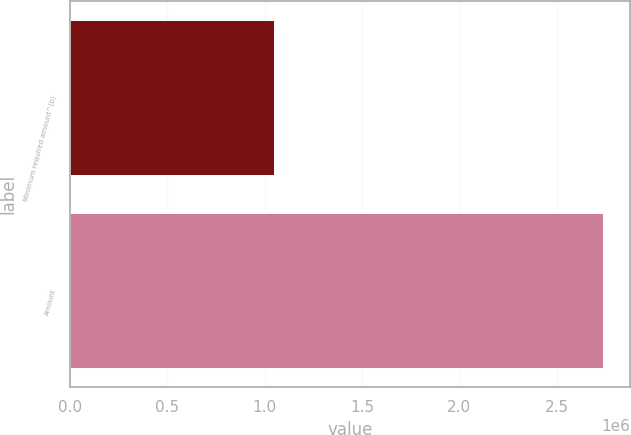Convert chart. <chart><loc_0><loc_0><loc_500><loc_500><bar_chart><fcel>Minimum required amount^(b)<fcel>Amount<nl><fcel>1.04718e+06<fcel>2.73998e+06<nl></chart> 